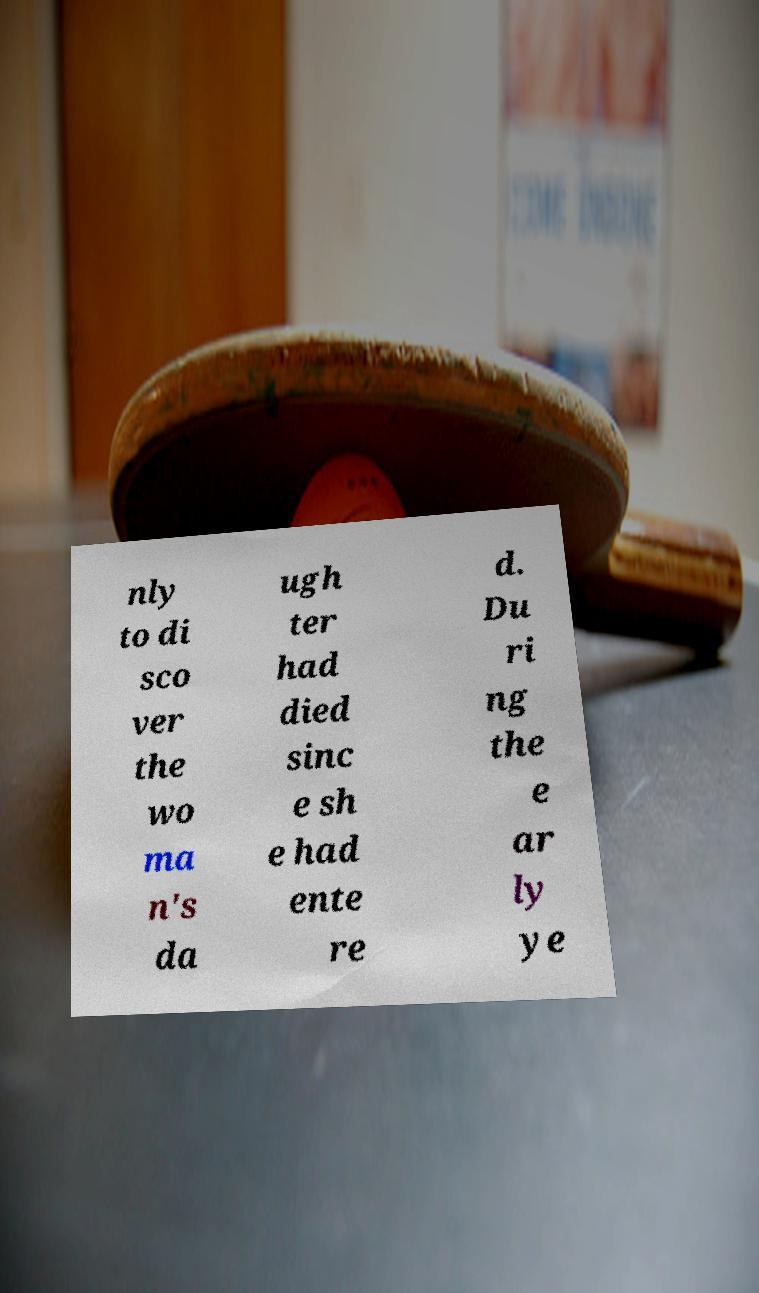For documentation purposes, I need the text within this image transcribed. Could you provide that? nly to di sco ver the wo ma n's da ugh ter had died sinc e sh e had ente re d. Du ri ng the e ar ly ye 